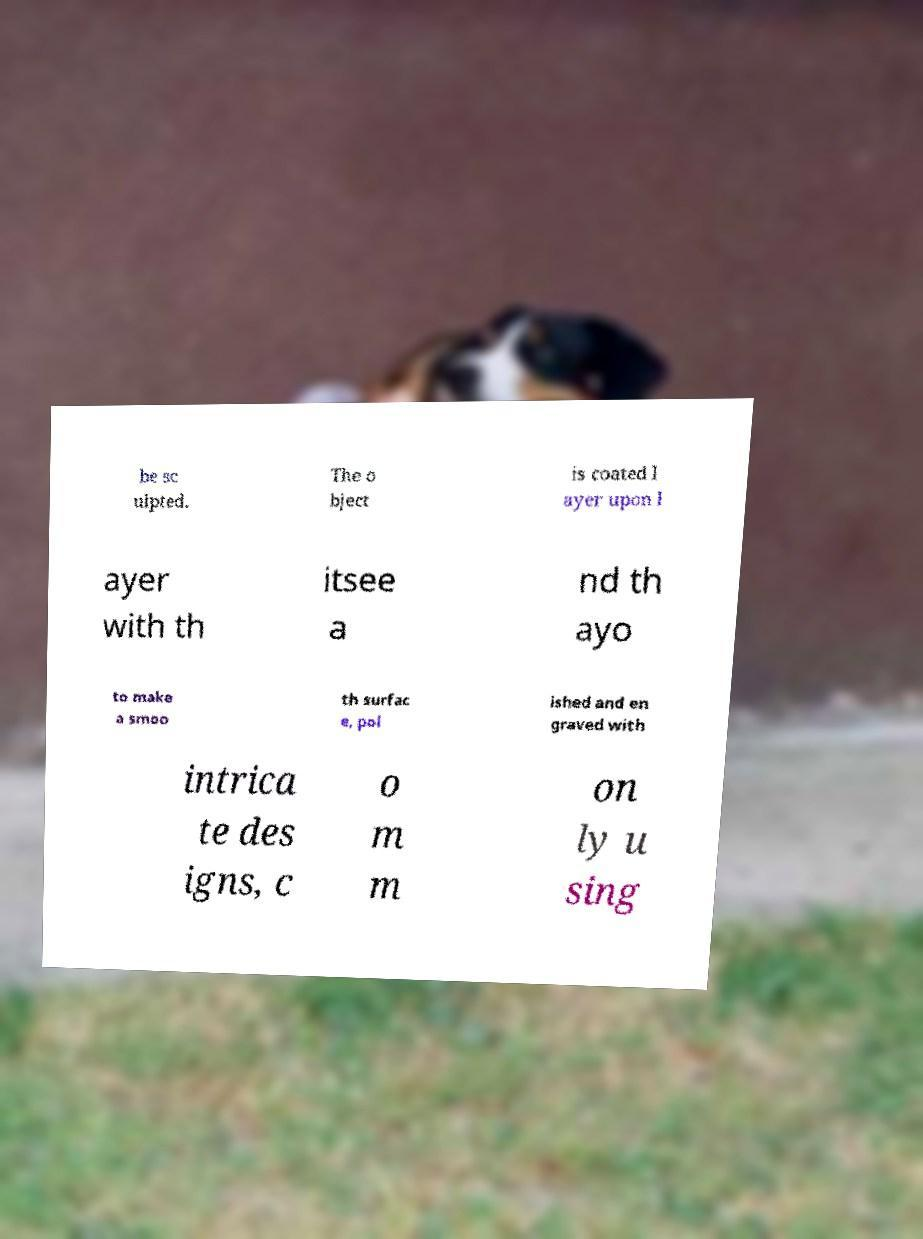There's text embedded in this image that I need extracted. Can you transcribe it verbatim? be sc ulpted. The o bject is coated l ayer upon l ayer with th itsee a nd th ayo to make a smoo th surfac e, pol ished and en graved with intrica te des igns, c o m m on ly u sing 